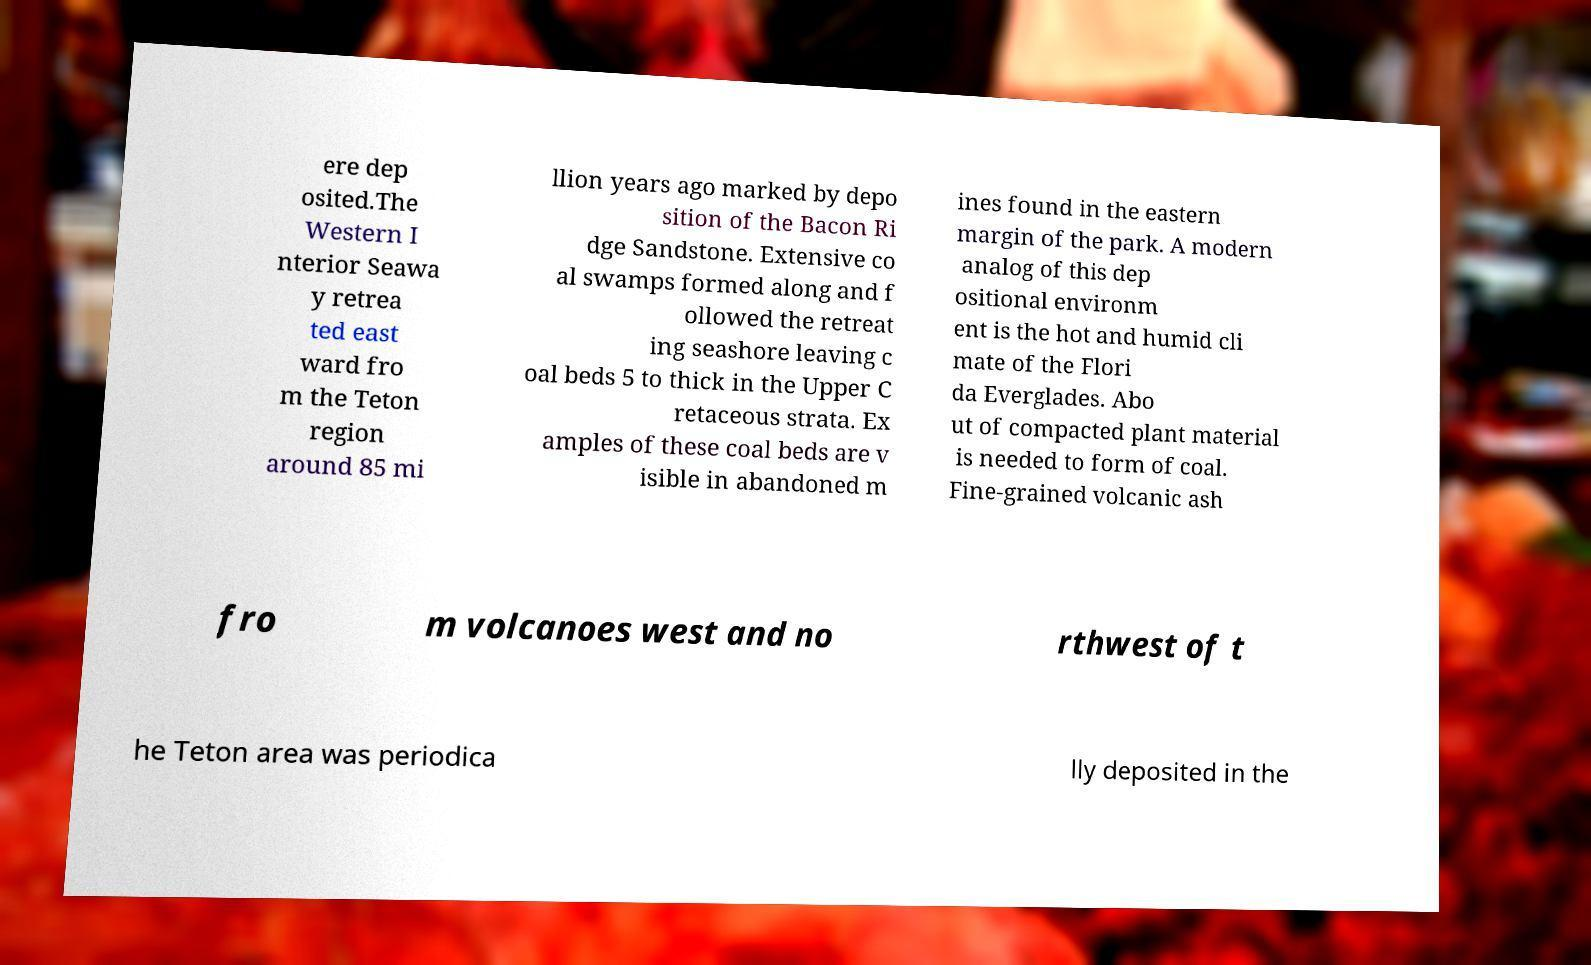For documentation purposes, I need the text within this image transcribed. Could you provide that? ere dep osited.The Western I nterior Seawa y retrea ted east ward fro m the Teton region around 85 mi llion years ago marked by depo sition of the Bacon Ri dge Sandstone. Extensive co al swamps formed along and f ollowed the retreat ing seashore leaving c oal beds 5 to thick in the Upper C retaceous strata. Ex amples of these coal beds are v isible in abandoned m ines found in the eastern margin of the park. A modern analog of this dep ositional environm ent is the hot and humid cli mate of the Flori da Everglades. Abo ut of compacted plant material is needed to form of coal. Fine-grained volcanic ash fro m volcanoes west and no rthwest of t he Teton area was periodica lly deposited in the 